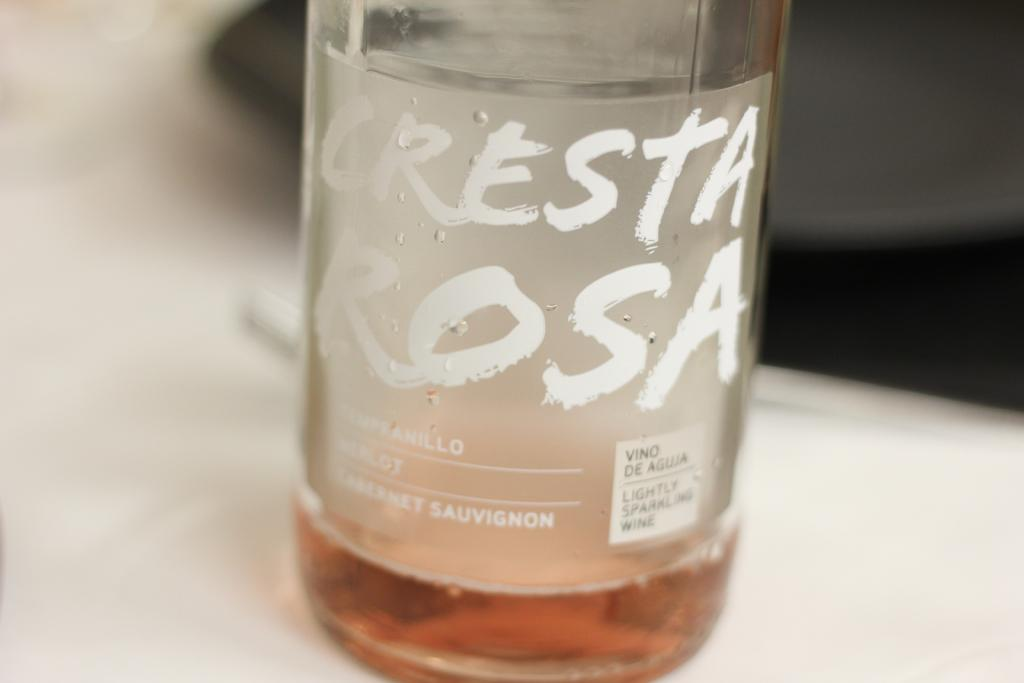<image>
Offer a succinct explanation of the picture presented. Almost empty bottle of Cresta Rosa on top of a table. 